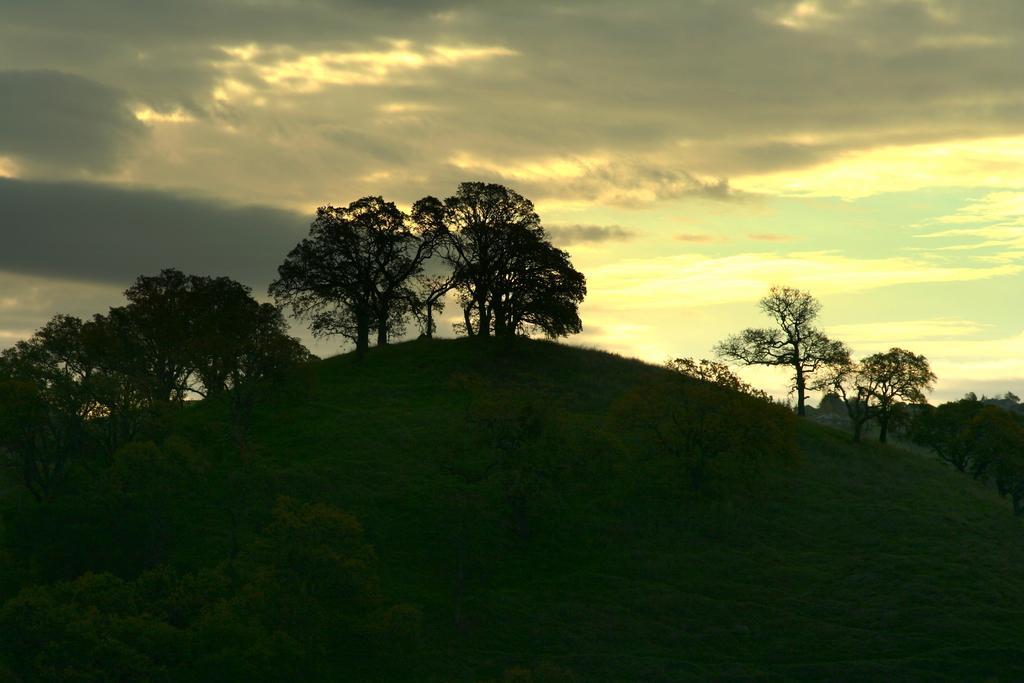Please provide a concise description of this image. Here I can see a hill on which there are some trees. At the bottom of the image I can see the grass. On the top of the image I can see the sky and clouds. 